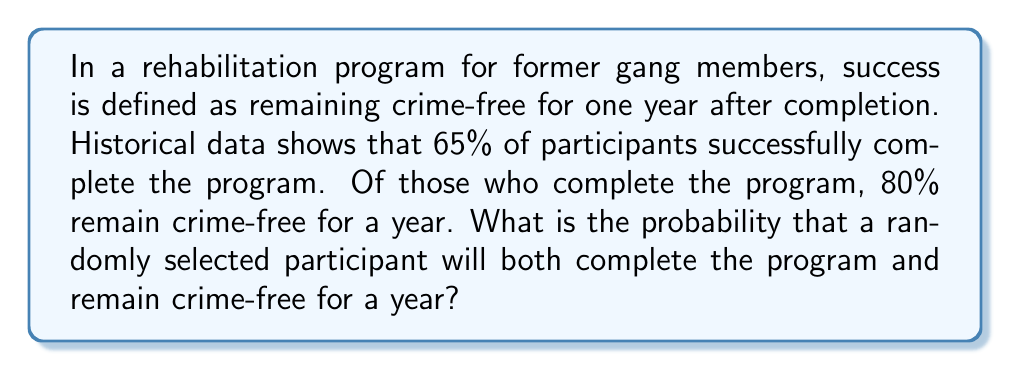Can you solve this math problem? Let's approach this step-by-step using the concept of conditional probability:

1) Define events:
   A: Participant completes the program
   B: Participant remains crime-free for a year

2) Given probabilities:
   $P(A) = 0.65$ (65% complete the program)
   $P(B|A) = 0.80$ (80% of those who complete remain crime-free)

3) We want to find $P(A \cap B)$, the probability of both completing the program and remaining crime-free.

4) Using the multiplication rule of probability:
   $P(A \cap B) = P(A) \cdot P(B|A)$

5) Substituting the values:
   $P(A \cap B) = 0.65 \cdot 0.80$

6) Calculate:
   $P(A \cap B) = 0.52$

Therefore, the probability that a randomly selected participant will both complete the program and remain crime-free for a year is 0.52 or 52%.
Answer: 0.52 or 52% 